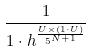<formula> <loc_0><loc_0><loc_500><loc_500>\frac { 1 } { 1 \cdot h ^ { \frac { U \times ( 1 \cdot U ) } { 5 ^ { N + 1 } } } }</formula> 